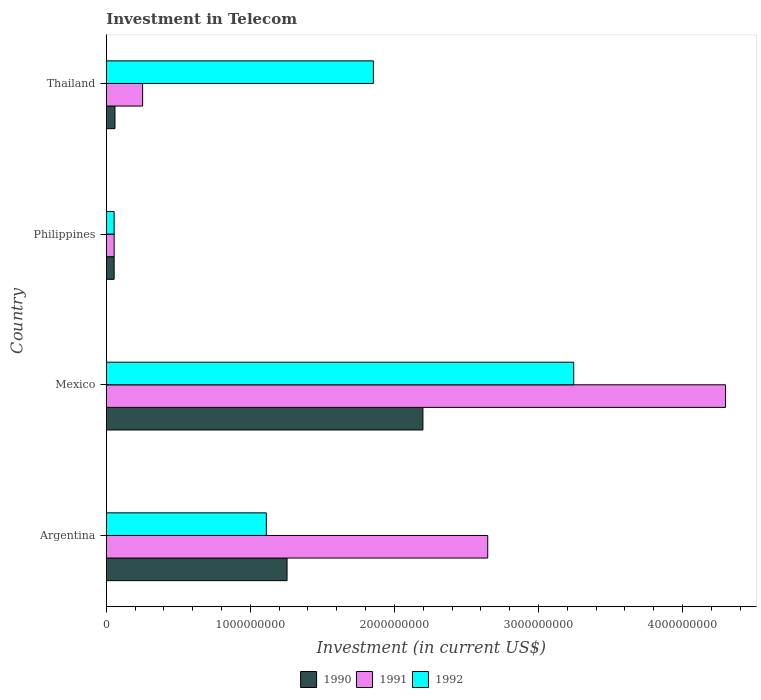How many groups of bars are there?
Give a very brief answer. 4. Are the number of bars on each tick of the Y-axis equal?
Offer a terse response. Yes. What is the label of the 2nd group of bars from the top?
Provide a short and direct response. Philippines. What is the amount invested in telecom in 1991 in Mexico?
Your answer should be compact. 4.30e+09. Across all countries, what is the maximum amount invested in telecom in 1990?
Give a very brief answer. 2.20e+09. Across all countries, what is the minimum amount invested in telecom in 1991?
Offer a terse response. 5.42e+07. In which country was the amount invested in telecom in 1990 maximum?
Provide a succinct answer. Mexico. In which country was the amount invested in telecom in 1992 minimum?
Ensure brevity in your answer.  Philippines. What is the total amount invested in telecom in 1991 in the graph?
Ensure brevity in your answer.  7.25e+09. What is the difference between the amount invested in telecom in 1990 in Mexico and that in Thailand?
Give a very brief answer. 2.14e+09. What is the difference between the amount invested in telecom in 1992 in Argentina and the amount invested in telecom in 1991 in Mexico?
Ensure brevity in your answer.  -3.19e+09. What is the average amount invested in telecom in 1992 per country?
Offer a terse response. 1.57e+09. What is the difference between the amount invested in telecom in 1991 and amount invested in telecom in 1990 in Mexico?
Provide a succinct answer. 2.10e+09. What is the ratio of the amount invested in telecom in 1991 in Philippines to that in Thailand?
Make the answer very short. 0.22. What is the difference between the highest and the second highest amount invested in telecom in 1990?
Provide a succinct answer. 9.43e+08. What is the difference between the highest and the lowest amount invested in telecom in 1991?
Give a very brief answer. 4.24e+09. What does the 2nd bar from the bottom in Philippines represents?
Provide a succinct answer. 1991. How many bars are there?
Your answer should be very brief. 12. Are all the bars in the graph horizontal?
Keep it short and to the point. Yes. How many countries are there in the graph?
Ensure brevity in your answer.  4. Does the graph contain grids?
Your answer should be very brief. No. Where does the legend appear in the graph?
Offer a very short reply. Bottom center. How many legend labels are there?
Provide a succinct answer. 3. How are the legend labels stacked?
Your response must be concise. Horizontal. What is the title of the graph?
Your response must be concise. Investment in Telecom. What is the label or title of the X-axis?
Your response must be concise. Investment (in current US$). What is the label or title of the Y-axis?
Provide a succinct answer. Country. What is the Investment (in current US$) of 1990 in Argentina?
Provide a short and direct response. 1.25e+09. What is the Investment (in current US$) in 1991 in Argentina?
Make the answer very short. 2.65e+09. What is the Investment (in current US$) of 1992 in Argentina?
Your answer should be very brief. 1.11e+09. What is the Investment (in current US$) of 1990 in Mexico?
Your answer should be compact. 2.20e+09. What is the Investment (in current US$) in 1991 in Mexico?
Offer a very short reply. 4.30e+09. What is the Investment (in current US$) in 1992 in Mexico?
Give a very brief answer. 3.24e+09. What is the Investment (in current US$) of 1990 in Philippines?
Make the answer very short. 5.42e+07. What is the Investment (in current US$) of 1991 in Philippines?
Offer a very short reply. 5.42e+07. What is the Investment (in current US$) of 1992 in Philippines?
Ensure brevity in your answer.  5.42e+07. What is the Investment (in current US$) in 1990 in Thailand?
Give a very brief answer. 6.00e+07. What is the Investment (in current US$) in 1991 in Thailand?
Your answer should be compact. 2.52e+08. What is the Investment (in current US$) of 1992 in Thailand?
Ensure brevity in your answer.  1.85e+09. Across all countries, what is the maximum Investment (in current US$) of 1990?
Provide a short and direct response. 2.20e+09. Across all countries, what is the maximum Investment (in current US$) in 1991?
Make the answer very short. 4.30e+09. Across all countries, what is the maximum Investment (in current US$) in 1992?
Offer a very short reply. 3.24e+09. Across all countries, what is the minimum Investment (in current US$) of 1990?
Provide a succinct answer. 5.42e+07. Across all countries, what is the minimum Investment (in current US$) of 1991?
Make the answer very short. 5.42e+07. Across all countries, what is the minimum Investment (in current US$) in 1992?
Offer a very short reply. 5.42e+07. What is the total Investment (in current US$) in 1990 in the graph?
Your answer should be very brief. 3.57e+09. What is the total Investment (in current US$) of 1991 in the graph?
Your response must be concise. 7.25e+09. What is the total Investment (in current US$) in 1992 in the graph?
Your response must be concise. 6.26e+09. What is the difference between the Investment (in current US$) of 1990 in Argentina and that in Mexico?
Ensure brevity in your answer.  -9.43e+08. What is the difference between the Investment (in current US$) in 1991 in Argentina and that in Mexico?
Your answer should be compact. -1.65e+09. What is the difference between the Investment (in current US$) in 1992 in Argentina and that in Mexico?
Give a very brief answer. -2.13e+09. What is the difference between the Investment (in current US$) of 1990 in Argentina and that in Philippines?
Your response must be concise. 1.20e+09. What is the difference between the Investment (in current US$) in 1991 in Argentina and that in Philippines?
Your answer should be compact. 2.59e+09. What is the difference between the Investment (in current US$) of 1992 in Argentina and that in Philippines?
Provide a short and direct response. 1.06e+09. What is the difference between the Investment (in current US$) of 1990 in Argentina and that in Thailand?
Ensure brevity in your answer.  1.19e+09. What is the difference between the Investment (in current US$) of 1991 in Argentina and that in Thailand?
Provide a succinct answer. 2.40e+09. What is the difference between the Investment (in current US$) in 1992 in Argentina and that in Thailand?
Your response must be concise. -7.43e+08. What is the difference between the Investment (in current US$) in 1990 in Mexico and that in Philippines?
Provide a short and direct response. 2.14e+09. What is the difference between the Investment (in current US$) of 1991 in Mexico and that in Philippines?
Keep it short and to the point. 4.24e+09. What is the difference between the Investment (in current US$) of 1992 in Mexico and that in Philippines?
Your answer should be very brief. 3.19e+09. What is the difference between the Investment (in current US$) in 1990 in Mexico and that in Thailand?
Provide a succinct answer. 2.14e+09. What is the difference between the Investment (in current US$) of 1991 in Mexico and that in Thailand?
Make the answer very short. 4.05e+09. What is the difference between the Investment (in current US$) of 1992 in Mexico and that in Thailand?
Your answer should be very brief. 1.39e+09. What is the difference between the Investment (in current US$) in 1990 in Philippines and that in Thailand?
Provide a short and direct response. -5.80e+06. What is the difference between the Investment (in current US$) of 1991 in Philippines and that in Thailand?
Offer a very short reply. -1.98e+08. What is the difference between the Investment (in current US$) in 1992 in Philippines and that in Thailand?
Keep it short and to the point. -1.80e+09. What is the difference between the Investment (in current US$) of 1990 in Argentina and the Investment (in current US$) of 1991 in Mexico?
Make the answer very short. -3.04e+09. What is the difference between the Investment (in current US$) in 1990 in Argentina and the Investment (in current US$) in 1992 in Mexico?
Provide a short and direct response. -1.99e+09. What is the difference between the Investment (in current US$) in 1991 in Argentina and the Investment (in current US$) in 1992 in Mexico?
Your response must be concise. -5.97e+08. What is the difference between the Investment (in current US$) in 1990 in Argentina and the Investment (in current US$) in 1991 in Philippines?
Your answer should be very brief. 1.20e+09. What is the difference between the Investment (in current US$) in 1990 in Argentina and the Investment (in current US$) in 1992 in Philippines?
Your response must be concise. 1.20e+09. What is the difference between the Investment (in current US$) in 1991 in Argentina and the Investment (in current US$) in 1992 in Philippines?
Provide a succinct answer. 2.59e+09. What is the difference between the Investment (in current US$) of 1990 in Argentina and the Investment (in current US$) of 1991 in Thailand?
Provide a succinct answer. 1.00e+09. What is the difference between the Investment (in current US$) of 1990 in Argentina and the Investment (in current US$) of 1992 in Thailand?
Keep it short and to the point. -5.99e+08. What is the difference between the Investment (in current US$) in 1991 in Argentina and the Investment (in current US$) in 1992 in Thailand?
Offer a very short reply. 7.94e+08. What is the difference between the Investment (in current US$) of 1990 in Mexico and the Investment (in current US$) of 1991 in Philippines?
Provide a succinct answer. 2.14e+09. What is the difference between the Investment (in current US$) of 1990 in Mexico and the Investment (in current US$) of 1992 in Philippines?
Offer a very short reply. 2.14e+09. What is the difference between the Investment (in current US$) of 1991 in Mexico and the Investment (in current US$) of 1992 in Philippines?
Offer a very short reply. 4.24e+09. What is the difference between the Investment (in current US$) of 1990 in Mexico and the Investment (in current US$) of 1991 in Thailand?
Provide a short and direct response. 1.95e+09. What is the difference between the Investment (in current US$) in 1990 in Mexico and the Investment (in current US$) in 1992 in Thailand?
Provide a short and direct response. 3.44e+08. What is the difference between the Investment (in current US$) in 1991 in Mexico and the Investment (in current US$) in 1992 in Thailand?
Your response must be concise. 2.44e+09. What is the difference between the Investment (in current US$) in 1990 in Philippines and the Investment (in current US$) in 1991 in Thailand?
Provide a succinct answer. -1.98e+08. What is the difference between the Investment (in current US$) in 1990 in Philippines and the Investment (in current US$) in 1992 in Thailand?
Provide a succinct answer. -1.80e+09. What is the difference between the Investment (in current US$) of 1991 in Philippines and the Investment (in current US$) of 1992 in Thailand?
Provide a short and direct response. -1.80e+09. What is the average Investment (in current US$) of 1990 per country?
Give a very brief answer. 8.92e+08. What is the average Investment (in current US$) of 1991 per country?
Offer a terse response. 1.81e+09. What is the average Investment (in current US$) in 1992 per country?
Provide a succinct answer. 1.57e+09. What is the difference between the Investment (in current US$) of 1990 and Investment (in current US$) of 1991 in Argentina?
Offer a very short reply. -1.39e+09. What is the difference between the Investment (in current US$) in 1990 and Investment (in current US$) in 1992 in Argentina?
Your response must be concise. 1.44e+08. What is the difference between the Investment (in current US$) in 1991 and Investment (in current US$) in 1992 in Argentina?
Make the answer very short. 1.54e+09. What is the difference between the Investment (in current US$) in 1990 and Investment (in current US$) in 1991 in Mexico?
Keep it short and to the point. -2.10e+09. What is the difference between the Investment (in current US$) in 1990 and Investment (in current US$) in 1992 in Mexico?
Make the answer very short. -1.05e+09. What is the difference between the Investment (in current US$) of 1991 and Investment (in current US$) of 1992 in Mexico?
Give a very brief answer. 1.05e+09. What is the difference between the Investment (in current US$) in 1991 and Investment (in current US$) in 1992 in Philippines?
Keep it short and to the point. 0. What is the difference between the Investment (in current US$) of 1990 and Investment (in current US$) of 1991 in Thailand?
Offer a very short reply. -1.92e+08. What is the difference between the Investment (in current US$) of 1990 and Investment (in current US$) of 1992 in Thailand?
Give a very brief answer. -1.79e+09. What is the difference between the Investment (in current US$) of 1991 and Investment (in current US$) of 1992 in Thailand?
Give a very brief answer. -1.60e+09. What is the ratio of the Investment (in current US$) in 1990 in Argentina to that in Mexico?
Offer a very short reply. 0.57. What is the ratio of the Investment (in current US$) in 1991 in Argentina to that in Mexico?
Provide a succinct answer. 0.62. What is the ratio of the Investment (in current US$) in 1992 in Argentina to that in Mexico?
Your answer should be compact. 0.34. What is the ratio of the Investment (in current US$) of 1990 in Argentina to that in Philippines?
Your answer should be very brief. 23.15. What is the ratio of the Investment (in current US$) of 1991 in Argentina to that in Philippines?
Offer a very short reply. 48.86. What is the ratio of the Investment (in current US$) of 1992 in Argentina to that in Philippines?
Your response must be concise. 20.5. What is the ratio of the Investment (in current US$) of 1990 in Argentina to that in Thailand?
Your answer should be very brief. 20.91. What is the ratio of the Investment (in current US$) of 1991 in Argentina to that in Thailand?
Your answer should be very brief. 10.51. What is the ratio of the Investment (in current US$) of 1992 in Argentina to that in Thailand?
Provide a succinct answer. 0.6. What is the ratio of the Investment (in current US$) in 1990 in Mexico to that in Philippines?
Your answer should be very brief. 40.55. What is the ratio of the Investment (in current US$) of 1991 in Mexico to that in Philippines?
Offer a terse response. 79.32. What is the ratio of the Investment (in current US$) of 1992 in Mexico to that in Philippines?
Make the answer very short. 59.87. What is the ratio of the Investment (in current US$) of 1990 in Mexico to that in Thailand?
Provide a succinct answer. 36.63. What is the ratio of the Investment (in current US$) in 1991 in Mexico to that in Thailand?
Keep it short and to the point. 17.06. What is the ratio of the Investment (in current US$) in 1992 in Mexico to that in Thailand?
Offer a very short reply. 1.75. What is the ratio of the Investment (in current US$) of 1990 in Philippines to that in Thailand?
Keep it short and to the point. 0.9. What is the ratio of the Investment (in current US$) in 1991 in Philippines to that in Thailand?
Make the answer very short. 0.22. What is the ratio of the Investment (in current US$) in 1992 in Philippines to that in Thailand?
Keep it short and to the point. 0.03. What is the difference between the highest and the second highest Investment (in current US$) in 1990?
Offer a terse response. 9.43e+08. What is the difference between the highest and the second highest Investment (in current US$) of 1991?
Make the answer very short. 1.65e+09. What is the difference between the highest and the second highest Investment (in current US$) in 1992?
Make the answer very short. 1.39e+09. What is the difference between the highest and the lowest Investment (in current US$) of 1990?
Give a very brief answer. 2.14e+09. What is the difference between the highest and the lowest Investment (in current US$) of 1991?
Provide a short and direct response. 4.24e+09. What is the difference between the highest and the lowest Investment (in current US$) of 1992?
Your answer should be very brief. 3.19e+09. 